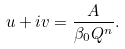Convert formula to latex. <formula><loc_0><loc_0><loc_500><loc_500>u + i v = \frac { A } { \beta _ { 0 } Q ^ { n } } .</formula> 